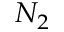Convert formula to latex. <formula><loc_0><loc_0><loc_500><loc_500>N _ { 2 }</formula> 